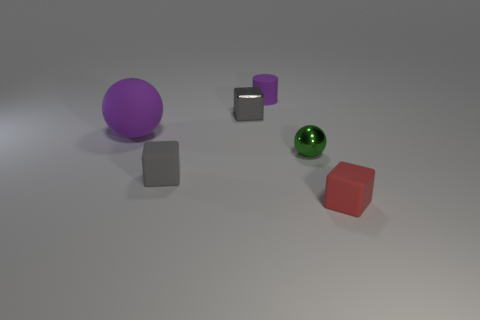The rubber object that is the same color as the tiny cylinder is what shape?
Your response must be concise. Sphere. There is a sphere behind the green metal ball that is in front of the shiny object behind the green sphere; what size is it?
Your answer should be very brief. Large. What is the material of the big purple thing?
Provide a succinct answer. Rubber. Are the red block and the ball on the right side of the gray matte cube made of the same material?
Offer a very short reply. No. Is there anything else that has the same color as the small ball?
Keep it short and to the point. No. There is a purple thing that is on the right side of the tiny matte object to the left of the cylinder; is there a gray rubber thing on the left side of it?
Provide a succinct answer. Yes. What is the color of the small cylinder?
Offer a very short reply. Purple. Are there any rubber things left of the red matte thing?
Keep it short and to the point. Yes. There is a red thing; is its shape the same as the gray metal object that is behind the small green shiny object?
Your answer should be compact. Yes. How many other things are the same material as the cylinder?
Your answer should be very brief. 3. 